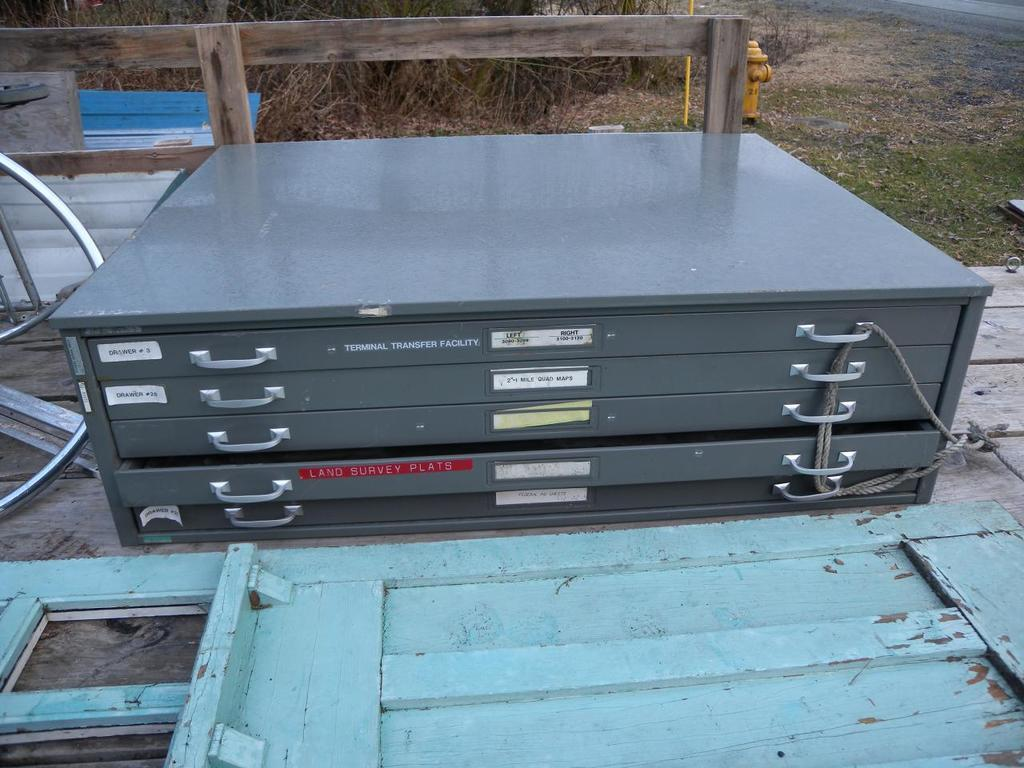<image>
Relay a brief, clear account of the picture shown. A set of metal map drawers has a red label on one drawer that says "land survey plats". 